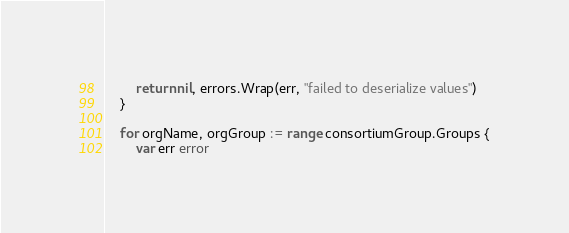<code> <loc_0><loc_0><loc_500><loc_500><_Go_>		return nil, errors.Wrap(err, "failed to deserialize values")
	}

	for orgName, orgGroup := range consortiumGroup.Groups {
		var err error</code> 